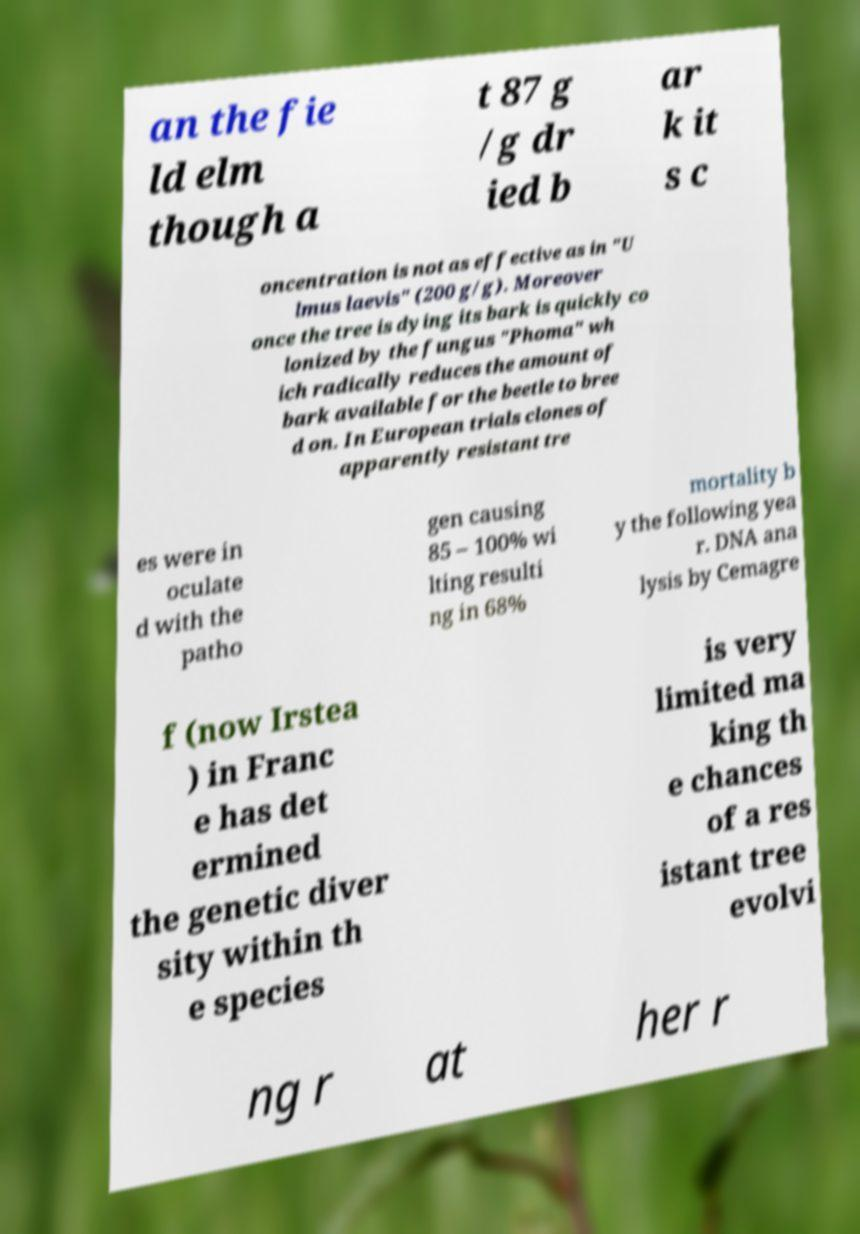There's text embedded in this image that I need extracted. Can you transcribe it verbatim? an the fie ld elm though a t 87 g /g dr ied b ar k it s c oncentration is not as effective as in "U lmus laevis" (200 g/g). Moreover once the tree is dying its bark is quickly co lonized by the fungus "Phoma" wh ich radically reduces the amount of bark available for the beetle to bree d on. In European trials clones of apparently resistant tre es were in oculate d with the patho gen causing 85 – 100% wi lting resulti ng in 68% mortality b y the following yea r. DNA ana lysis by Cemagre f (now Irstea ) in Franc e has det ermined the genetic diver sity within th e species is very limited ma king th e chances of a res istant tree evolvi ng r at her r 